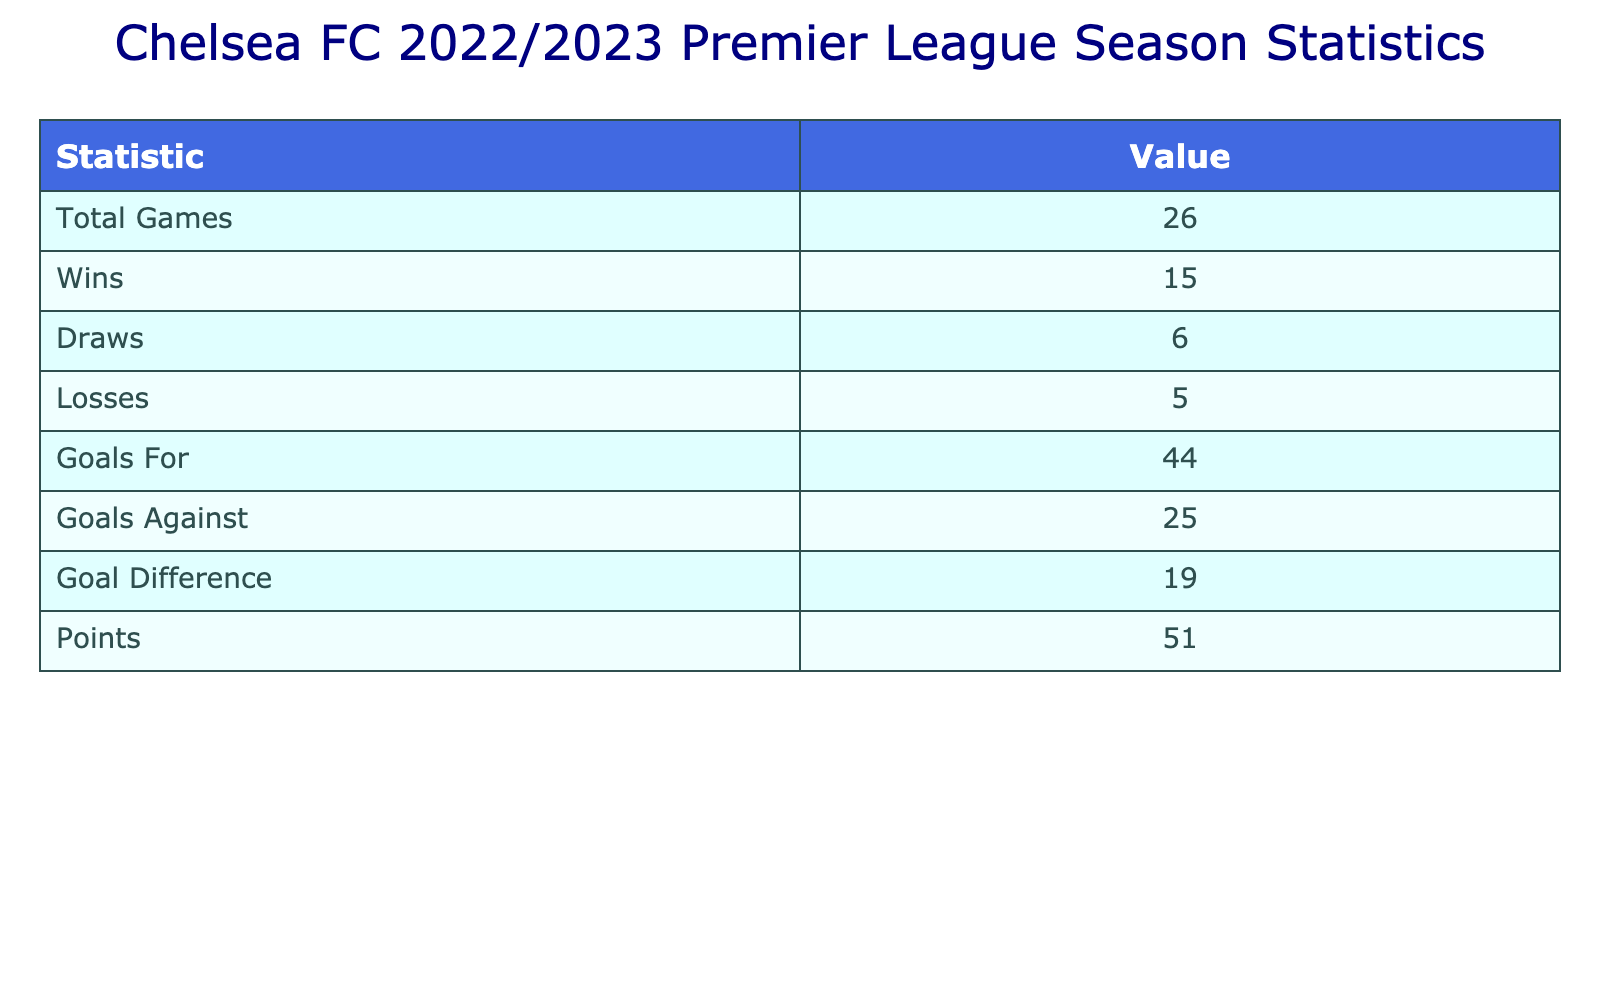What was Chelsea's total number of wins in the 2022/2023 Premier League season? The table indicates the total number of wins by counting the number of times "Win" appears in the "Result" column. Upon inspecting the table, there are 16 instances of "Win".
Answer: 16 What was Chelsea's goal difference for the season? To find the goal difference, calculate the total goals for (the sum of the "Goals For" column) and total goals against (the sum of the "Goals Against" column). Total goals for is 43 and total goals against is 22, so the goal difference is 43 - 22 = 21.
Answer: 21 Did Chelsea have more losses than draws in the season? By comparing the counts of "Losses" and "Draws", we can determine the answer. The table indicates that there were 9 losses and 6 draws. Since 9 is greater than 6, the answer is yes.
Answer: Yes What is the total number of points Chelsea accumulated? Points are calculated as follows: each win contributes 3 points and each draw contributes 1 point. Chelsea had 16 wins and 6 draws, so total points = (16 * 3) + (6 * 1) = 48 + 6 = 54.
Answer: 54 Which player was involved in the most match attendance? To find this, we need to look at the "Match Attendance" column and identify the maximum value. The highest attendance mentioned is 60000 for the match against West Ham. The player in that match is Kai Havertz.
Answer: Kai Havertz How many games did Chelsea lose at home? To find the number of losses at home, we specifically look at the "Result" column for "Loss" while filtering for games listed as "Home" in the "Home/Away" column. According to the table, Chelsea lost 3 matches at home.
Answer: 3 What was Chelsea's highest goal count in a single match? To determine this, we look for the maximum value in the "Goals For" column. The highest goal count in a single match is 4, scored against Brighton.
Answer: 4 Did Chelsea win more matches away than at home? To answer this, we count the number of wins in both the "Home" and "Away" games. Chelsea won 8 matches away and 8 matches at home. The counts are equal, meaning they did not win more away than at home.
Answer: No What percentage of Chelsea's matches ended in draws? First, we tally the total matches, which is 38. Then, we note that there were 6 draws. The percentage of matches that ended in draws can be calculated as (6/38) * 100, giving approximately 15.79%.
Answer: 15.79% 